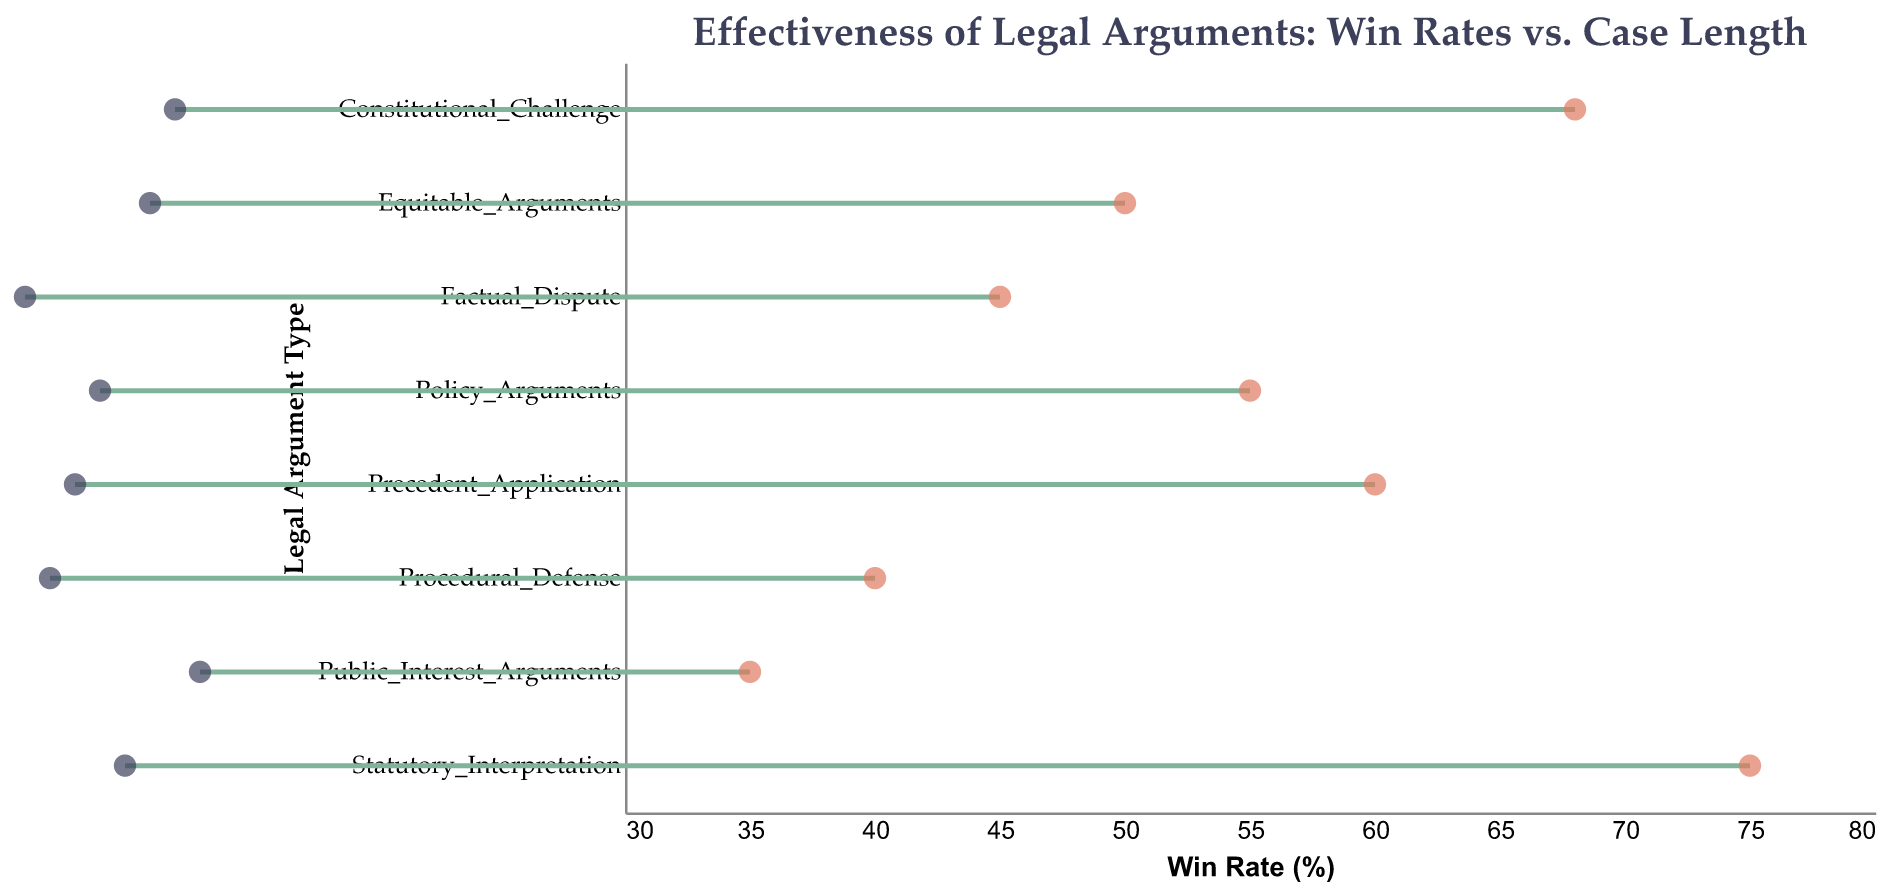What is the title of the figure? The title of the figure is displayed prominently at the top and reads "Effectiveness of Legal Arguments: Win Rates vs. Case Length".
Answer: Effectiveness of Legal Arguments: Win Rates vs. Case Length How many different types of legal arguments are displayed in the figure? By counting the distinct points or labels on the y-axis, we can determine that there are 8 types of legal arguments presented in the figure.
Answer: 8 Which legal argument type has the highest win rate? By observing the x-axis values for win rate, the point farthest to the right represents the highest win rate, which corresponds to "Statutory Interpretation" with a win rate of 75%.
Answer: Statutory Interpretation Which type of legal argument has the longest average case length? The "Public Interest Arguments" legal argument type is farthest to the right on the x-axis for case length, indicating that it has the longest average case length of 13 months.
Answer: Public Interest Arguments What is the difference in win rate between "Precedent Application" and "Equitable Arguments"? The win rate for "Precedent Application" is 60%, and for "Equitable Arguments" it is 50%. The difference is 60% - 50% = 10%.
Answer: 10% Which type of legal argument tends to resolve more quickly on average, "Factual Dispute" or "Constitutional Challenge"? By comparing the x-axis positions for case lengths, "Factual Dispute" has an average case length of 6 months, while "Constitutional Challenge" has 12 months. This means "Factual Dispute" resolves more quickly.
Answer: Factual Dispute Are there any legal argument types with a win rate below 50% but an average case length above 10 months? By scanning the plot, "Public Interest Arguments" has a win rate of 35% and an average case length of 13 months, fitting the criteria.
Answer: Yes What is the average win rate across all legal arguments shown? Sum of the win rates is 75 + 68 + 60 + 55 + 50 + 45 + 40 + 35 = 428. There are 8 legal arguments, so the average is 428 / 8 = 53.5%.
Answer: 53.5% Which argument types have a win rate exactly equal to 50% and what are their case lengths? "Equitable Arguments" has a win rate of exactly 50% and its average case length is 11 months.
Answer: Equitable Arguments, 11 months Describe the performance of "Procedural Defense" in terms of win rate and case length. "Procedural Defense" has a win rate of 40% and an average case length of 7 months, as depicted by their positions on the x-axis corresponding to these values.
Answer: 40% win rate, 7 months case length 